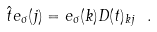<formula> <loc_0><loc_0><loc_500><loc_500>\hat { t } e _ { \sigma } ( j ) = e _ { \sigma } ( k ) D ( t ) _ { k j } \ .</formula> 